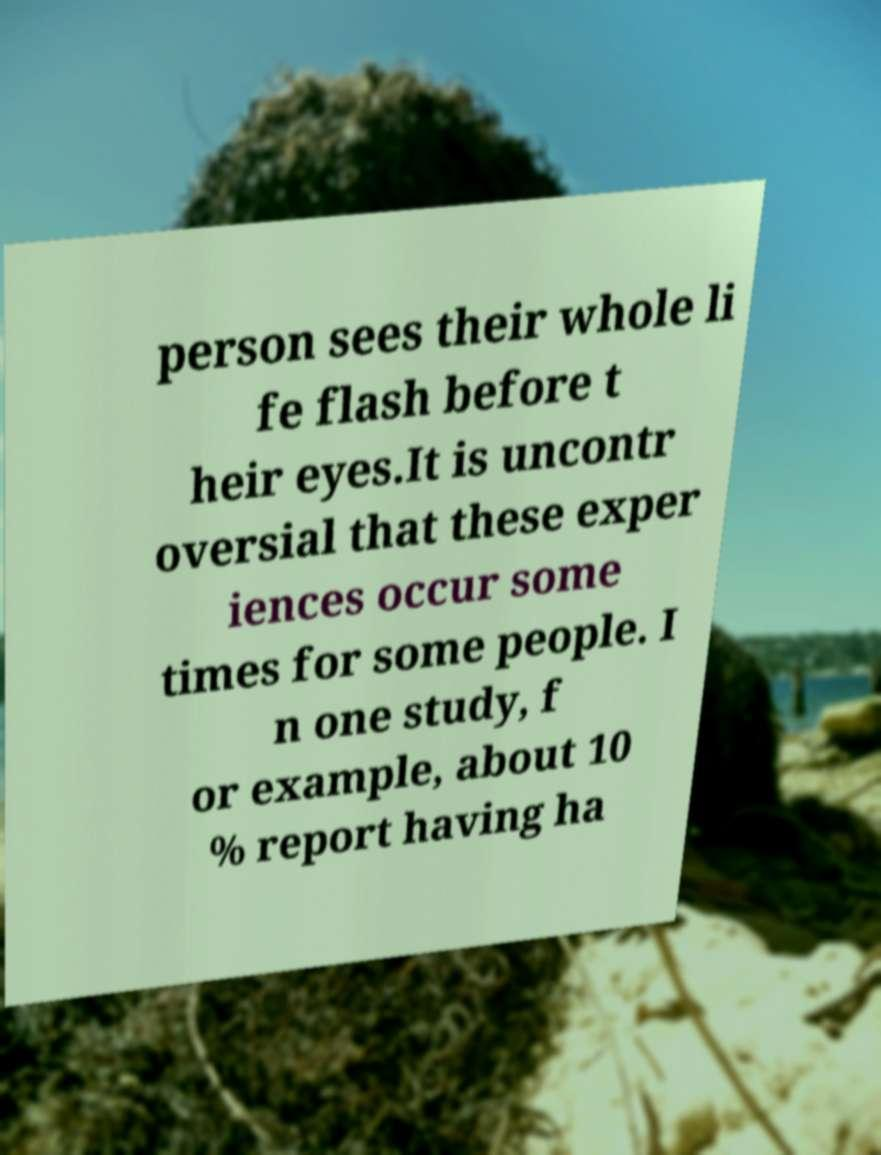Please read and relay the text visible in this image. What does it say? person sees their whole li fe flash before t heir eyes.It is uncontr oversial that these exper iences occur some times for some people. I n one study, f or example, about 10 % report having ha 